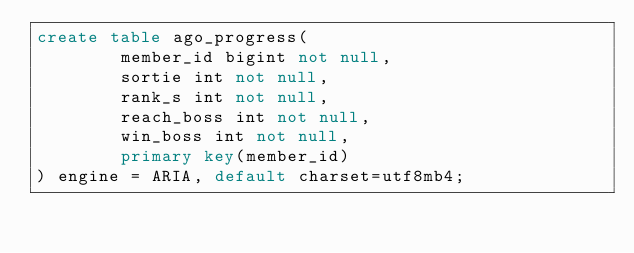<code> <loc_0><loc_0><loc_500><loc_500><_SQL_>create table ago_progress(
        member_id bigint not null,
        sortie int not null,
        rank_s int not null,
        reach_boss int not null,
        win_boss int not null,
        primary key(member_id)
) engine = ARIA, default charset=utf8mb4;
</code> 